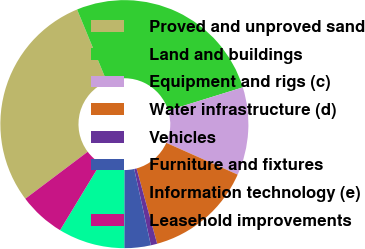<chart> <loc_0><loc_0><loc_500><loc_500><pie_chart><fcel>Proved and unproved sand<fcel>Land and buildings<fcel>Equipment and rigs (c)<fcel>Water infrastructure (d)<fcel>Vehicles<fcel>Furniture and fixtures<fcel>Information technology (e)<fcel>Leasehold improvements<nl><fcel>29.04%<fcel>26.43%<fcel>11.46%<fcel>14.07%<fcel>0.83%<fcel>3.44%<fcel>8.66%<fcel>6.05%<nl></chart> 